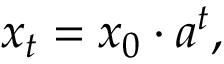<formula> <loc_0><loc_0><loc_500><loc_500>x _ { t } = x _ { 0 } \cdot a ^ { t } ,</formula> 